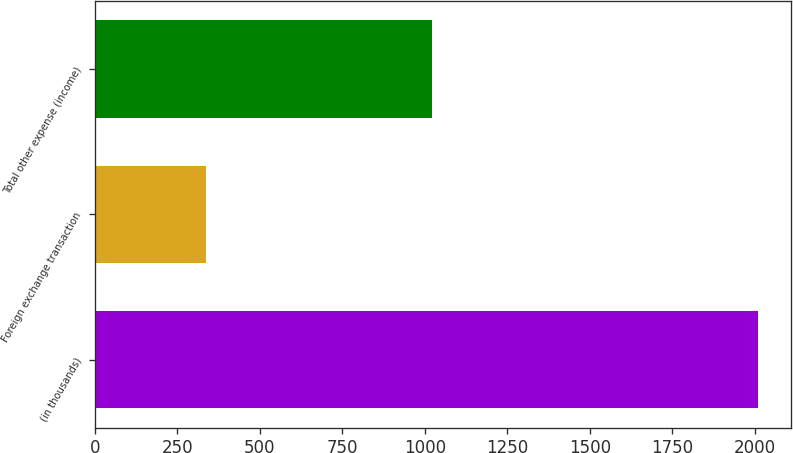Convert chart to OTSL. <chart><loc_0><loc_0><loc_500><loc_500><bar_chart><fcel>(in thousands)<fcel>Foreign exchange transaction<fcel>Total other expense (income)<nl><fcel>2009<fcel>336<fcel>1023<nl></chart> 